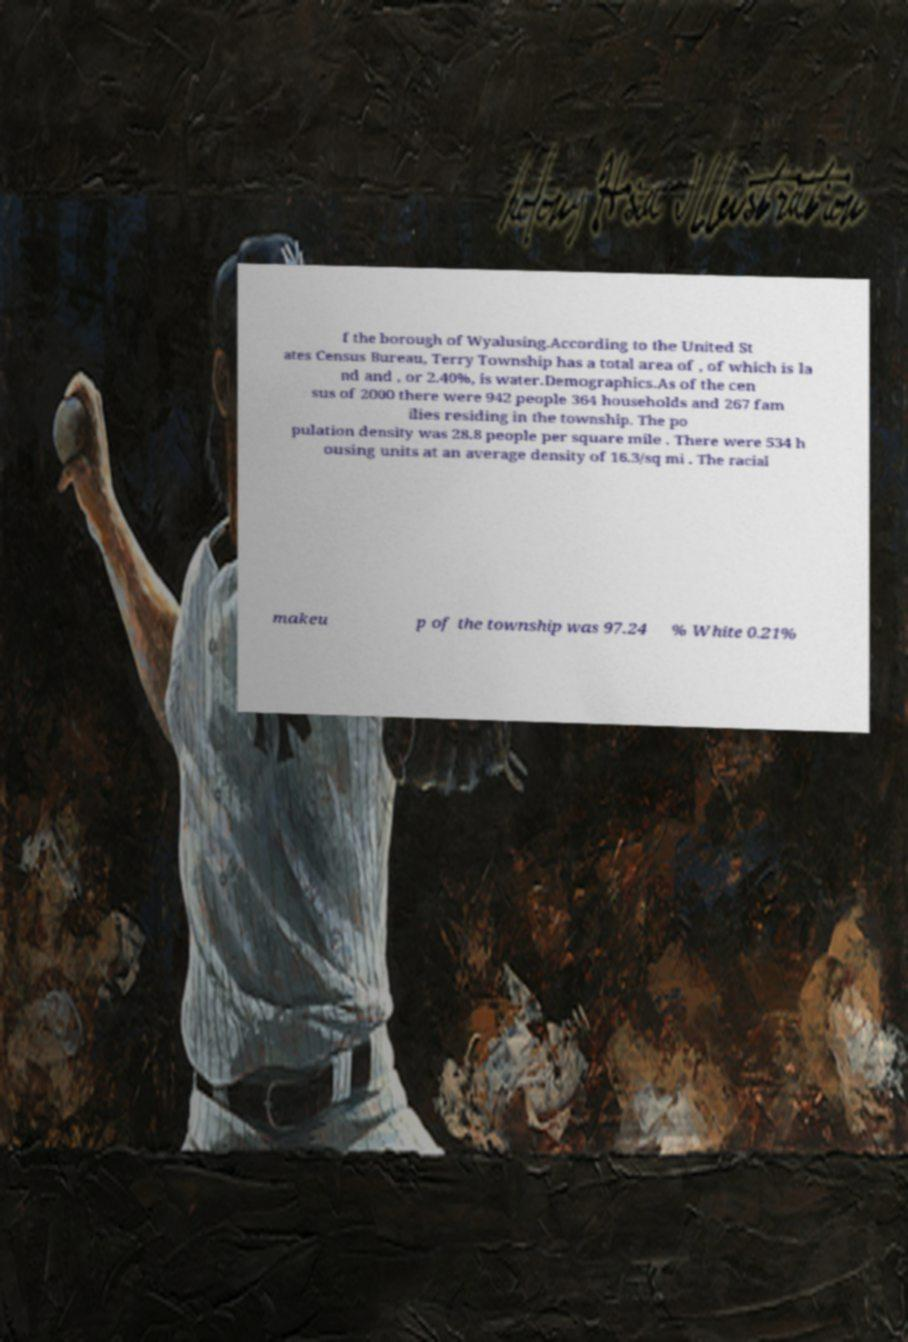There's text embedded in this image that I need extracted. Can you transcribe it verbatim? f the borough of Wyalusing.According to the United St ates Census Bureau, Terry Township has a total area of , of which is la nd and , or 2.40%, is water.Demographics.As of the cen sus of 2000 there were 942 people 364 households and 267 fam ilies residing in the township. The po pulation density was 28.8 people per square mile . There were 534 h ousing units at an average density of 16.3/sq mi . The racial makeu p of the township was 97.24 % White 0.21% 